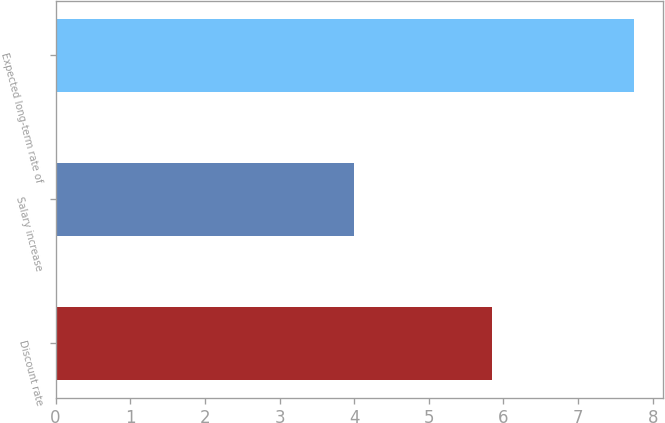Convert chart. <chart><loc_0><loc_0><loc_500><loc_500><bar_chart><fcel>Discount rate<fcel>Salary increase<fcel>Expected long-term rate of<nl><fcel>5.85<fcel>4<fcel>7.75<nl></chart> 